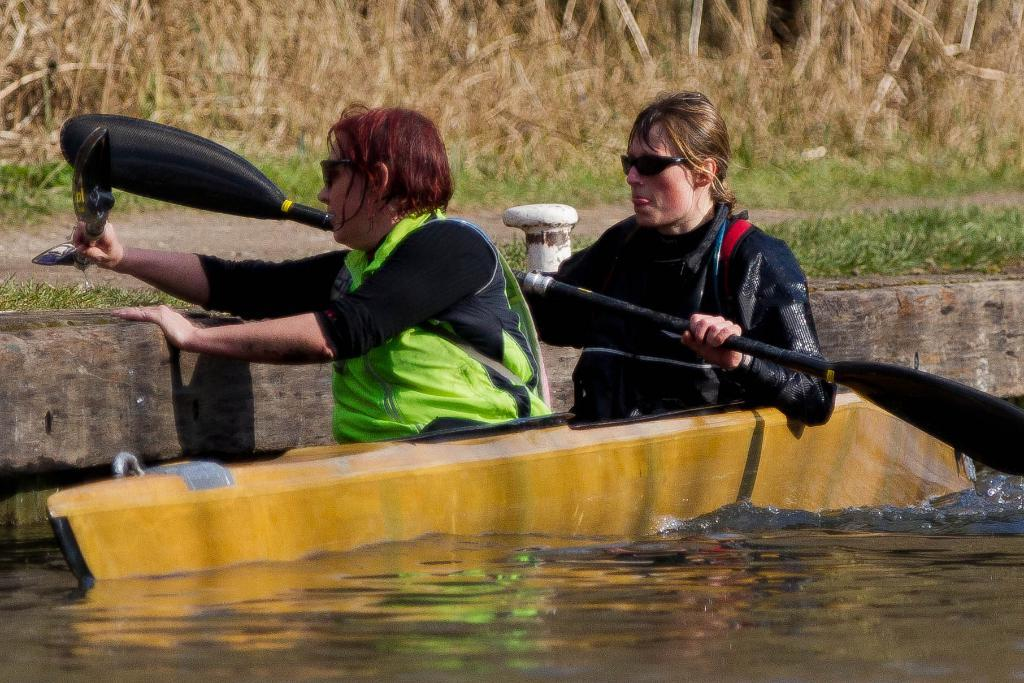How many people are in the image? There are two people in the image. What are the two people doing in the image? The two people are sitting in a boat. What can be seen in the background of the image? There is grass visible in the background of the image. What type of flowers can be seen in the image? There are no flowers present in the image. Is there a car visible in the image? There is no car present in the image. 